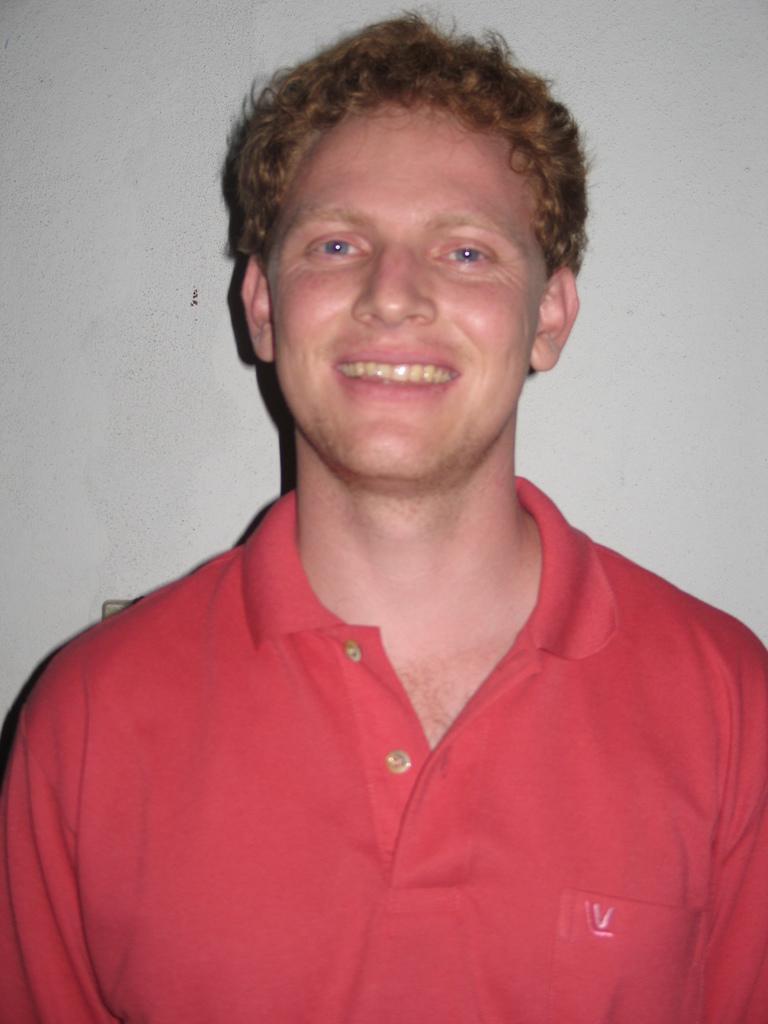Can you describe this image briefly? In this image I can see a person smiling. He is wearing a red t shirt and there is a white background. 